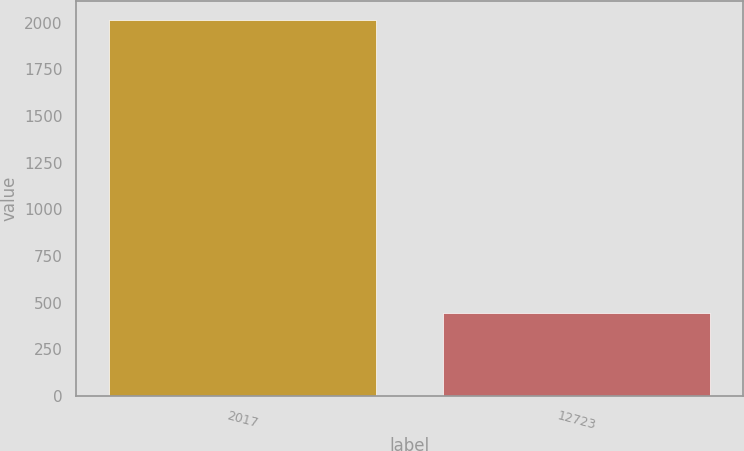Convert chart. <chart><loc_0><loc_0><loc_500><loc_500><bar_chart><fcel>2017<fcel>12723<nl><fcel>2014<fcel>442<nl></chart> 